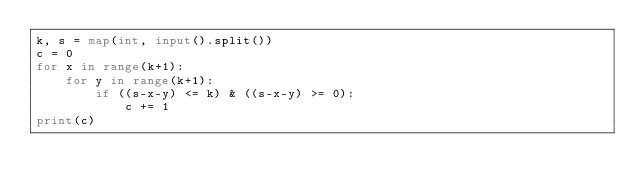<code> <loc_0><loc_0><loc_500><loc_500><_Python_>k, s = map(int, input().split())
c = 0
for x in range(k+1):
    for y in range(k+1):
        if ((s-x-y) <= k) & ((s-x-y) >= 0):
            c += 1
print(c)</code> 